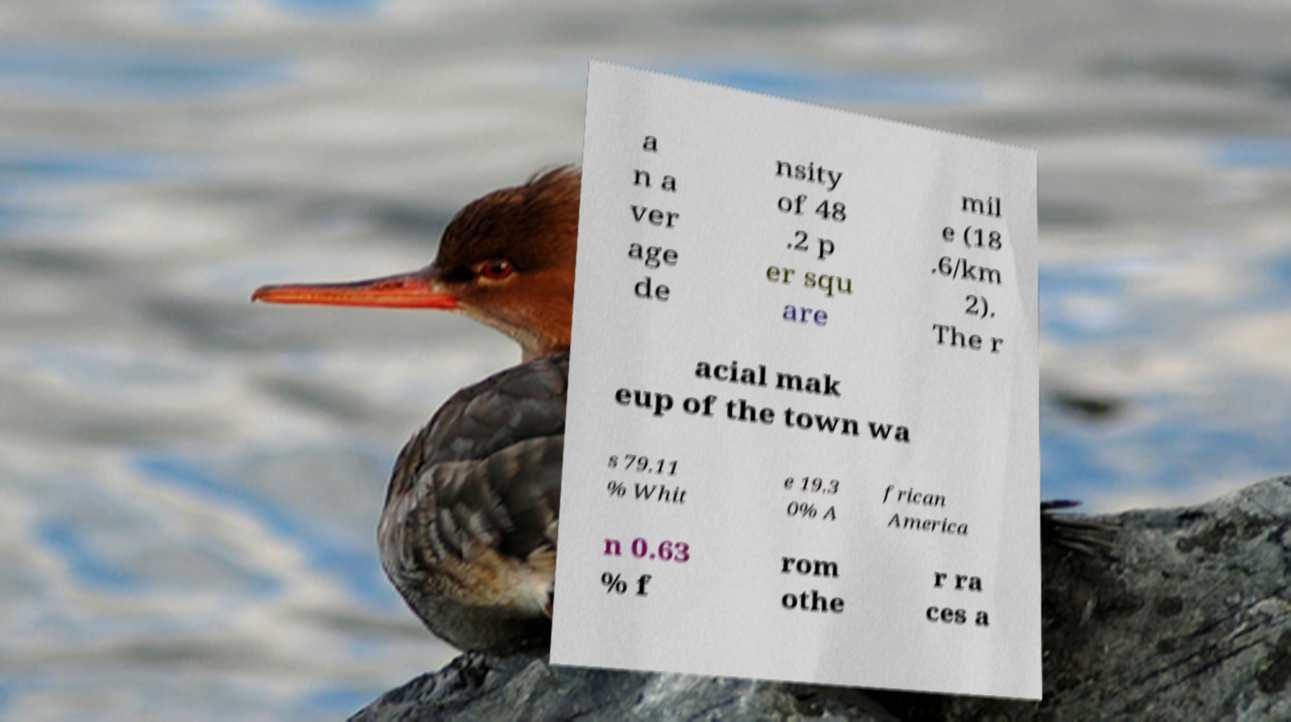Can you accurately transcribe the text from the provided image for me? a n a ver age de nsity of 48 .2 p er squ are mil e (18 .6/km 2). The r acial mak eup of the town wa s 79.11 % Whit e 19.3 0% A frican America n 0.63 % f rom othe r ra ces a 